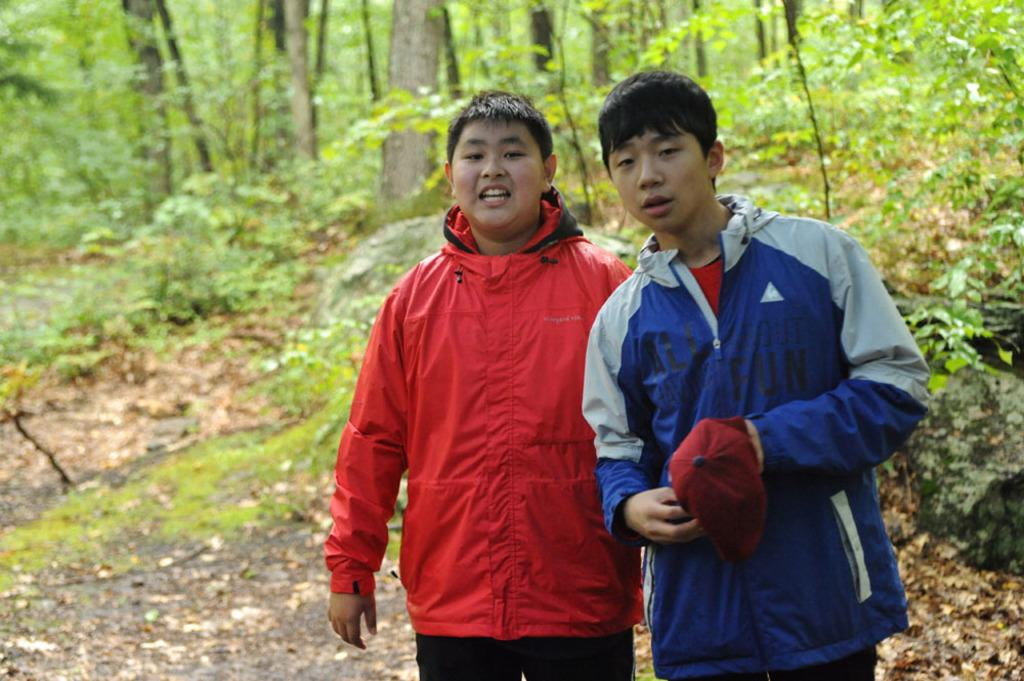What can be seen in the foreground of the image? There are persons standing in the front of the image. What is visible in the background of the image? There are trees in the background of the image. What type of vegetation is present on the ground in the image? There is grass on the ground in the image. What else can be found on the ground in the image? There are dry leaves on the ground in the image. What type of rhythm can be seen in the pattern of the dry leaves? There is no rhythm present in the design of the dry leaves, as they are simply scattered on the ground. Can you tell me how many oranges are hanging from the trees in the image? There are no oranges present in the image; only trees are visible in the background. 